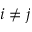<formula> <loc_0><loc_0><loc_500><loc_500>i \neq j</formula> 